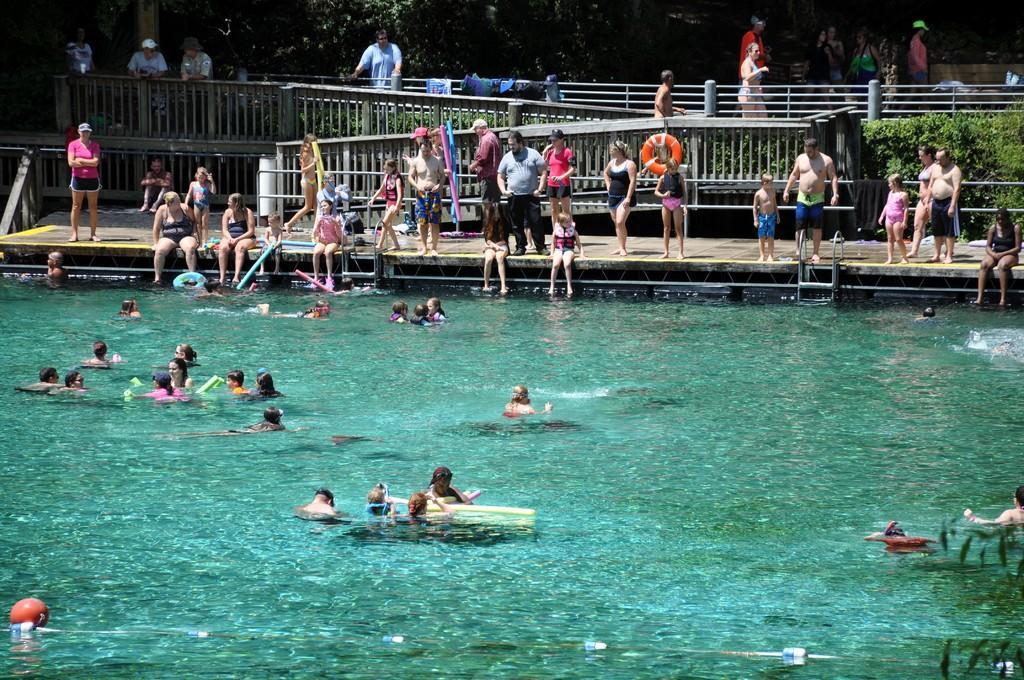Describe this image in one or two sentences. This is the picture of a swimming pool. In this image there are group of people swimming in the water. At the back there are group of people sitting and standing and there are clothes on the railing. There are trees and plants. At the bottom there is water. 